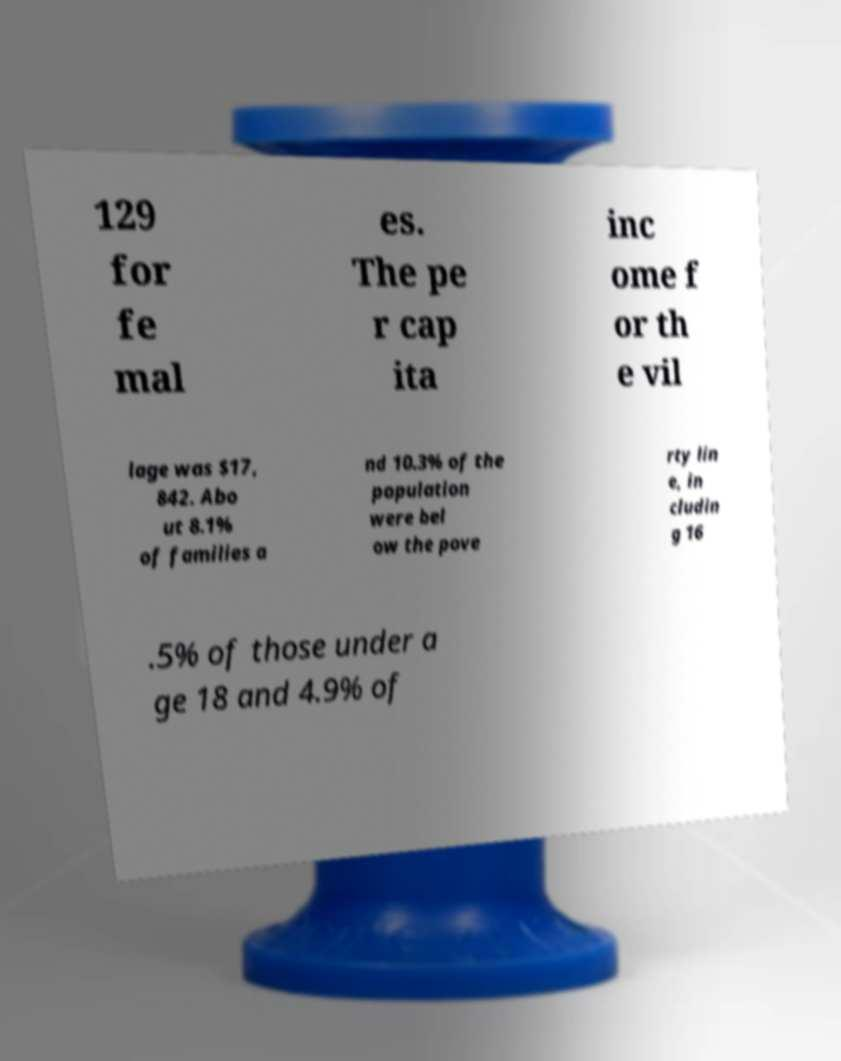There's text embedded in this image that I need extracted. Can you transcribe it verbatim? 129 for fe mal es. The pe r cap ita inc ome f or th e vil lage was $17, 842. Abo ut 8.1% of families a nd 10.3% of the population were bel ow the pove rty lin e, in cludin g 16 .5% of those under a ge 18 and 4.9% of 